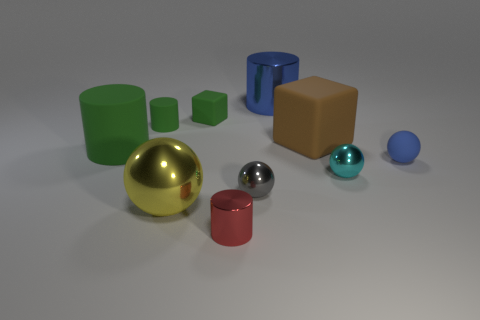Subtract all tiny matte spheres. How many spheres are left? 3 Subtract all cyan cylinders. Subtract all brown cubes. How many cylinders are left? 4 Subtract all cylinders. How many objects are left? 6 Subtract all small gray blocks. Subtract all tiny gray metallic spheres. How many objects are left? 9 Add 2 blue objects. How many blue objects are left? 4 Add 6 brown matte things. How many brown matte things exist? 7 Subtract 1 brown cubes. How many objects are left? 9 